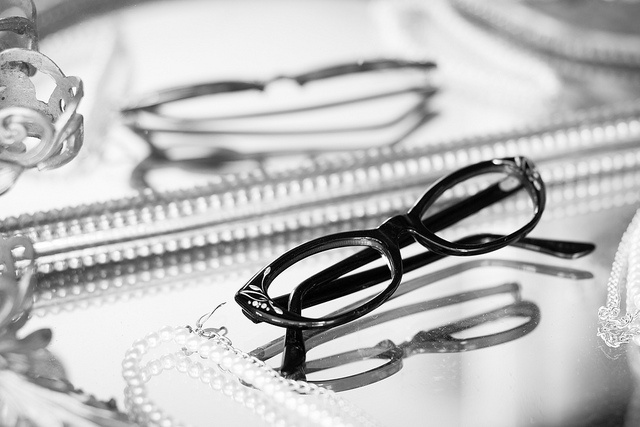Describe the objects in this image and their specific colors. I can see various objects in this image with different colors. 